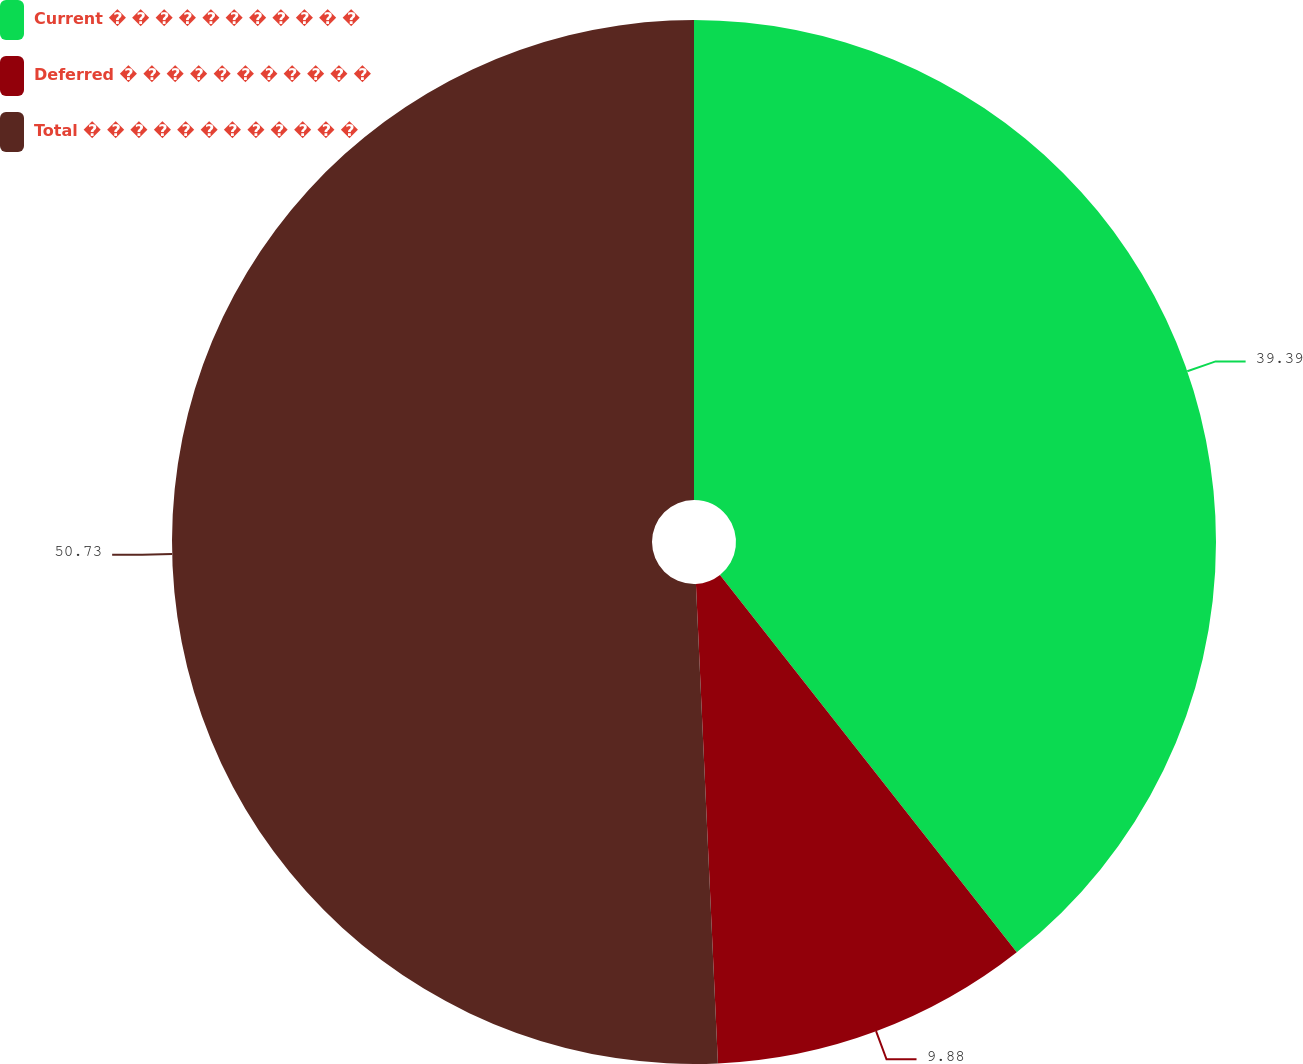Convert chart to OTSL. <chart><loc_0><loc_0><loc_500><loc_500><pie_chart><fcel>Current � � � � � � � � � � �<fcel>Deferred � � � � � � � � � � �<fcel>Total � � � � � � � � � � � �<nl><fcel>39.39%<fcel>9.88%<fcel>50.73%<nl></chart> 